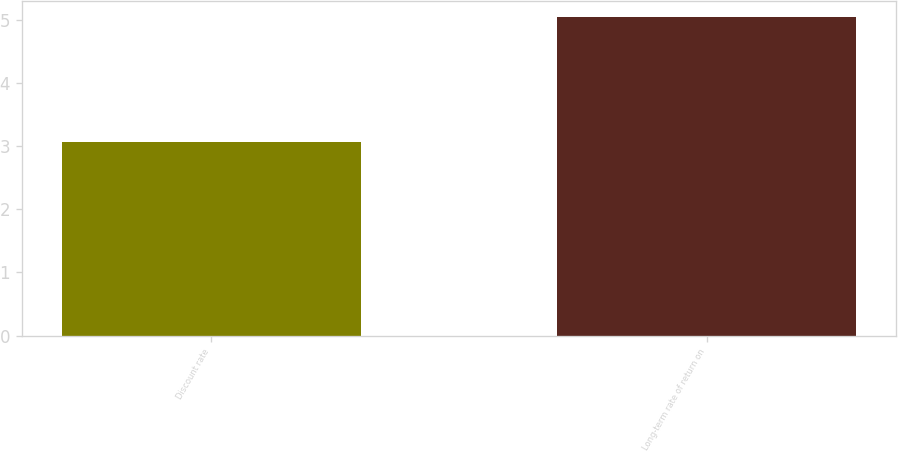<chart> <loc_0><loc_0><loc_500><loc_500><bar_chart><fcel>Discount rate<fcel>Long-term rate of return on<nl><fcel>3.06<fcel>5.05<nl></chart> 